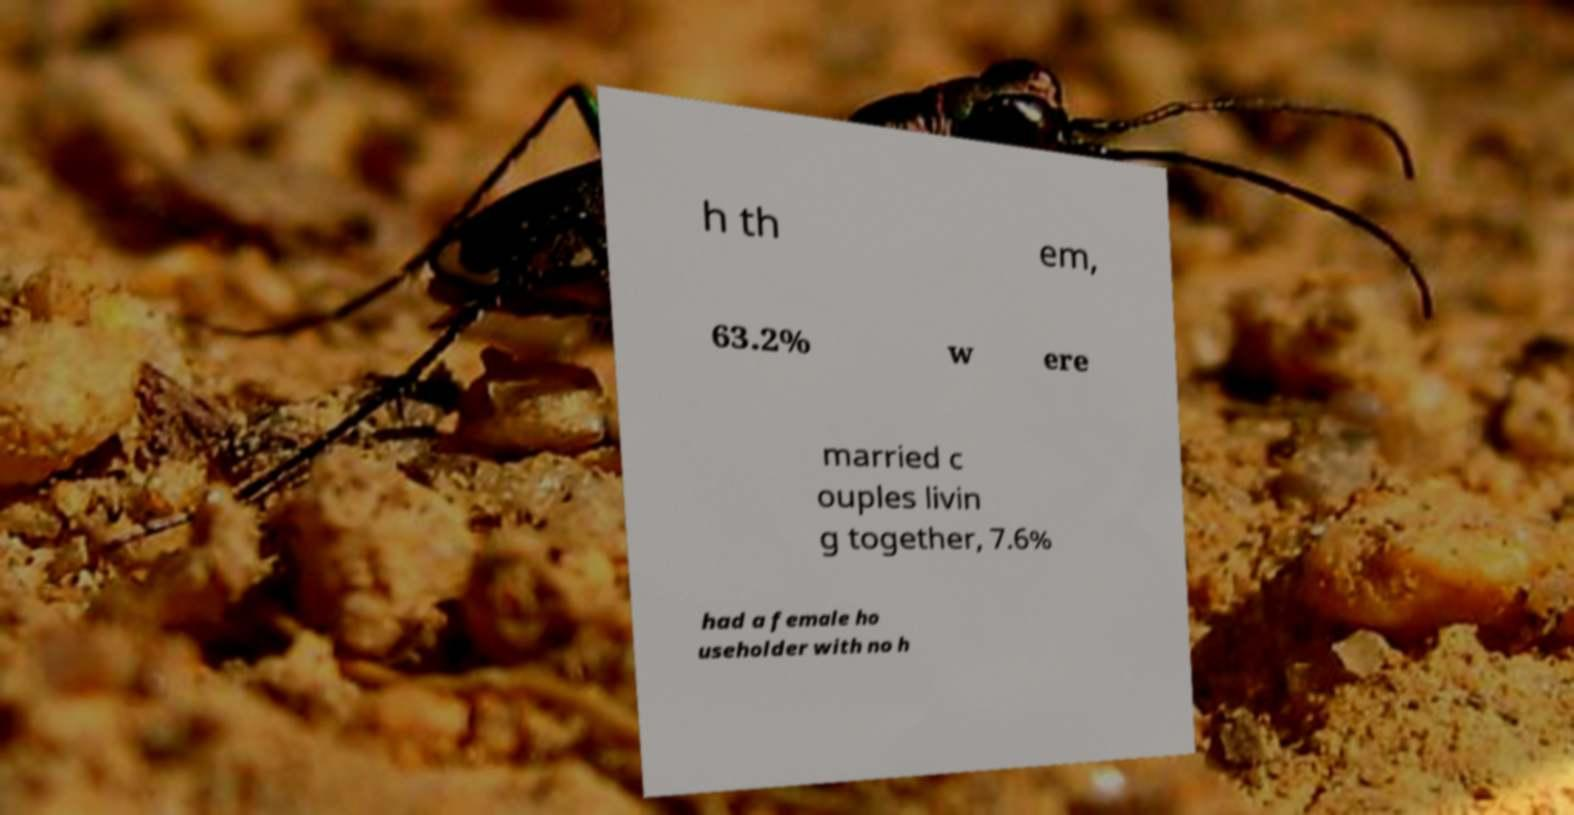Please read and relay the text visible in this image. What does it say? h th em, 63.2% w ere married c ouples livin g together, 7.6% had a female ho useholder with no h 